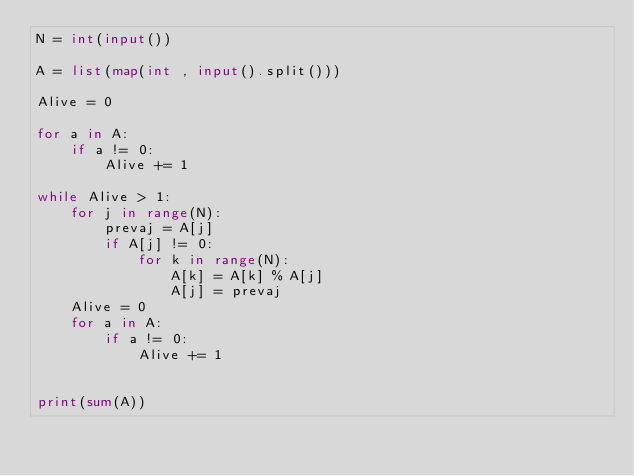<code> <loc_0><loc_0><loc_500><loc_500><_Python_>N = int(input())

A = list(map(int , input().split()))

Alive = 0

for a in A:
	if a != 0:
		Alive += 1

while Alive > 1:
	for j in range(N):
		prevaj = A[j]
		if A[j] != 0:
			for k in range(N):
				A[k] = A[k] % A[j]
				A[j] = prevaj
	Alive = 0
	for a in A:
		if a != 0:
			Alive += 1


print(sum(A))</code> 